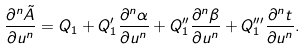<formula> <loc_0><loc_0><loc_500><loc_500>\frac { \partial ^ { n } \tilde { A } } { \partial u ^ { n } } = Q _ { 1 } + Q _ { 1 } ^ { \prime } \frac { \partial ^ { n } \alpha } { \partial u ^ { n } } + Q _ { 1 } ^ { \prime \prime } \frac { \partial ^ { n } \beta } { \partial u ^ { n } } + Q _ { 1 } ^ { \prime \prime \prime } \frac { \partial ^ { n } t } { \partial u ^ { n } } .</formula> 